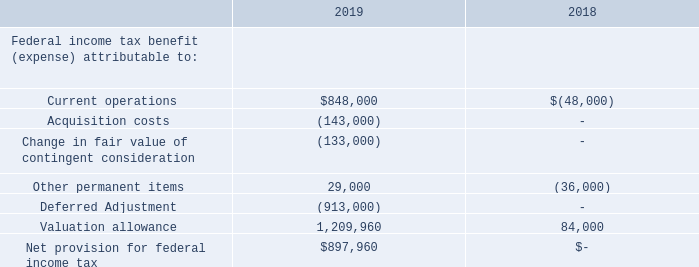NOTE 15 – INCOME TAXES
As of December 31, 2019, the Company had net operating loss carry-forwards for federal income tax purposes of approximately $18.3 million, consisting of pre-2018 losses in the amount of approximately $14.3 million that expire from 2020 through 2037, and post-2017 losses in the amount of approximately $4 million that never expire. These net operating losses are available to offset future taxable income. The Company was formed in 2006 as a limited liability company and changed to a corporation in 2007. Activity prior to incorporation is not reflected in the Company’s corporate tax returns. In the future, the cumulative net operating loss carry-forward for income tax purposes may differ from the cumulative financial statement loss due to timing differences between book and tax reporting.
The provision for Federal income tax consists of the following for the years ended December 31, 2019 and 2018:
The provision for Federal income tax consists of the following for the years ended December 31, 2019 and 2018:
How much was the net operating loss carry-forwards for federal income tax purposes as of December 31, 2019? Approximately $18.3 million. When was the Company formed? 2006. How much was the net provision for federal income tax in 2019?  $897,960. What is the percentage change in valuation allowance in 2019 compared to 2018?
Answer scale should be: percent. (1,209,960 - 84,000)/84,000 
Answer: 1340.43. What is the ratio of total federal income tax benefit to total expenses in 2019? (848,000+29,000+1,209,960)/(143,000+133,000+913,000) 
Answer: 1.76. What is the average of current operations from 2018 to 2019? (848,000+(-48,000))/2 
Answer: 400000. 